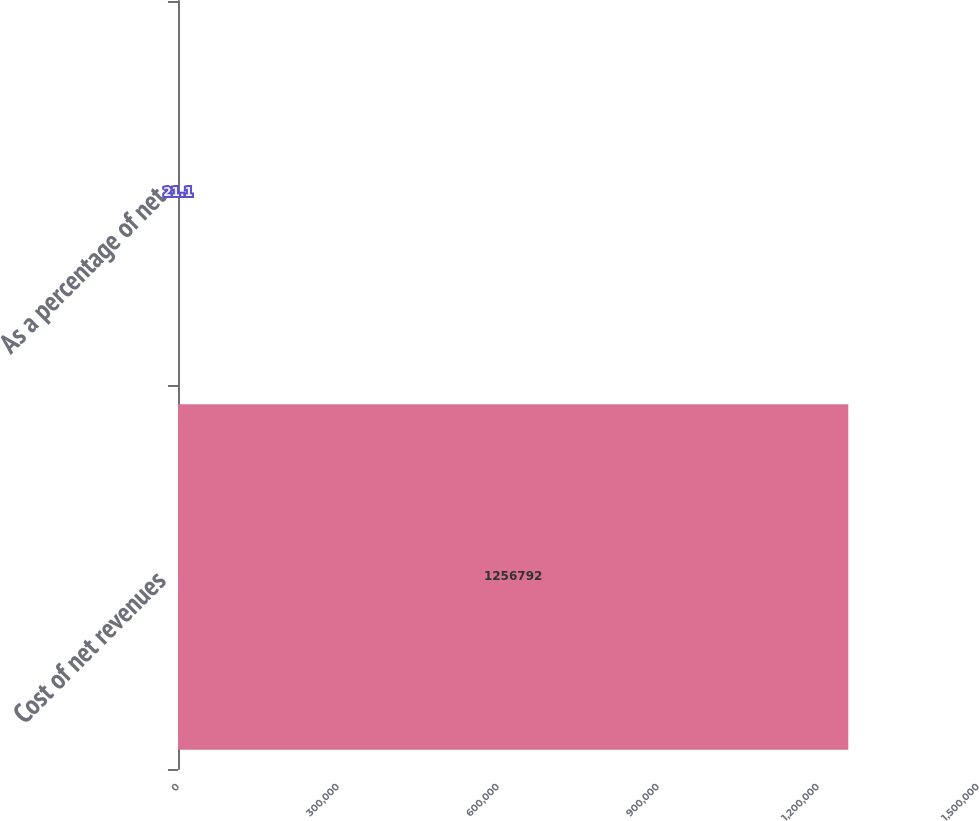Convert chart to OTSL. <chart><loc_0><loc_0><loc_500><loc_500><bar_chart><fcel>Cost of net revenues<fcel>As a percentage of net<nl><fcel>1.25679e+06<fcel>21.1<nl></chart> 